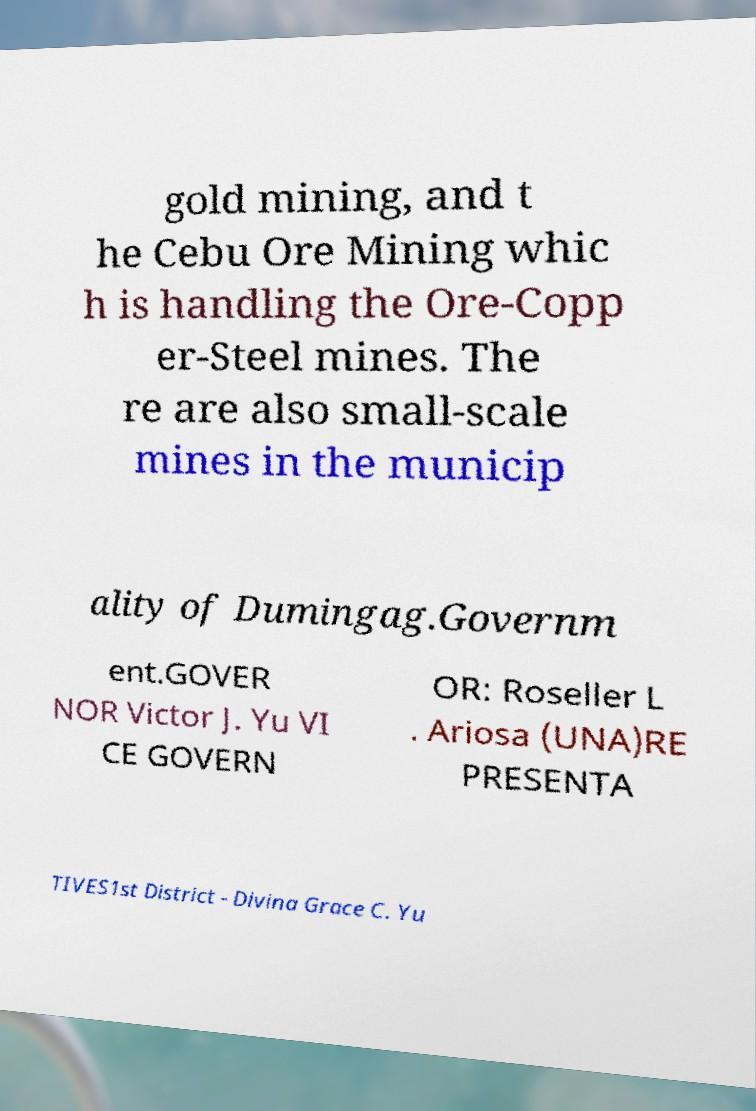Please read and relay the text visible in this image. What does it say? gold mining, and t he Cebu Ore Mining whic h is handling the Ore-Copp er-Steel mines. The re are also small-scale mines in the municip ality of Dumingag.Governm ent.GOVER NOR Victor J. Yu VI CE GOVERN OR: Roseller L . Ariosa (UNA)RE PRESENTA TIVES1st District - Divina Grace C. Yu 